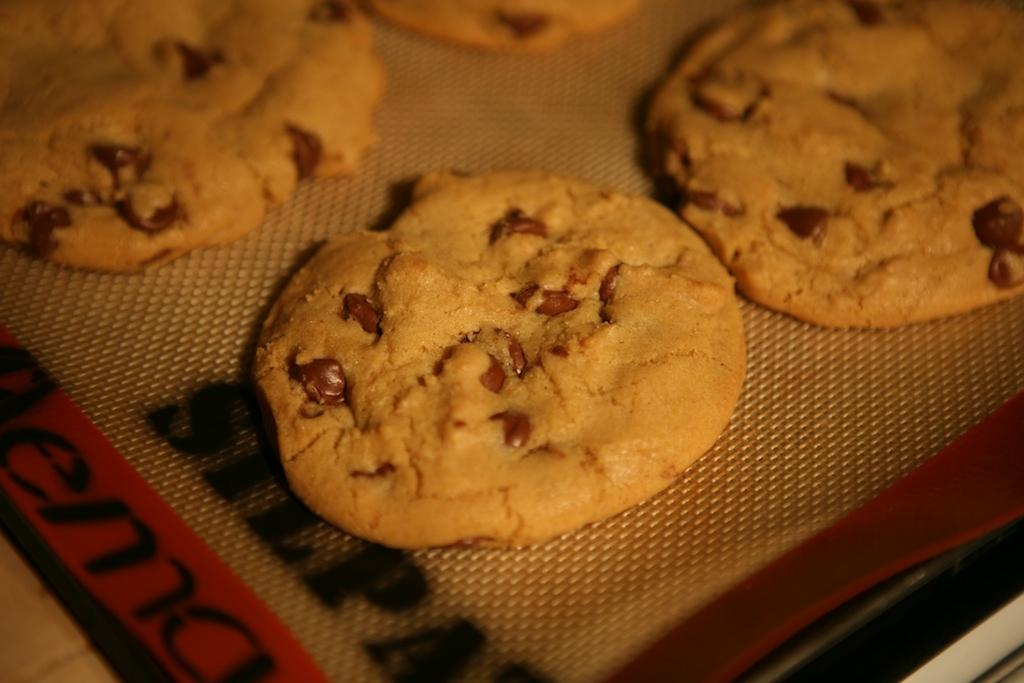What type of cookies can be seen in the image? There are chocolate chip cookies in the image. Where are the cookies placed? The cookies are on a platform. What type of key is used to unlock the carpenter's toolbox in the image? There is no key or carpenter's toolbox present in the image; it only features chocolate chip cookies on a platform. 